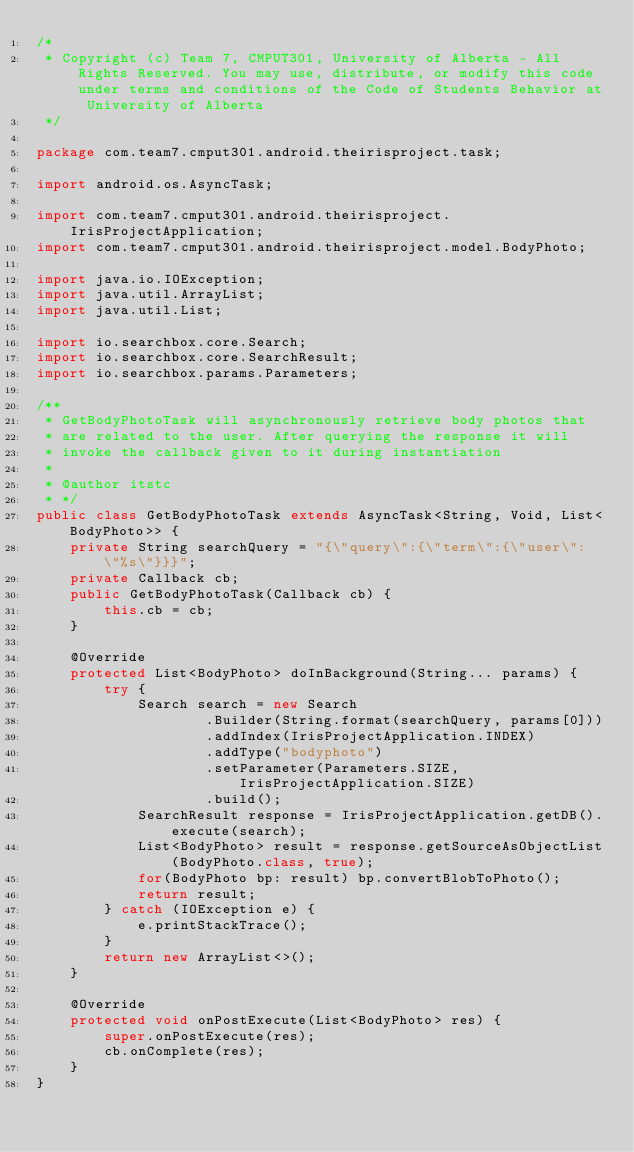Convert code to text. <code><loc_0><loc_0><loc_500><loc_500><_Java_>/*
 * Copyright (c) Team 7, CMPUT301, University of Alberta - All Rights Reserved. You may use, distribute, or modify this code under terms and conditions of the Code of Students Behavior at University of Alberta
 */

package com.team7.cmput301.android.theirisproject.task;

import android.os.AsyncTask;

import com.team7.cmput301.android.theirisproject.IrisProjectApplication;
import com.team7.cmput301.android.theirisproject.model.BodyPhoto;

import java.io.IOException;
import java.util.ArrayList;
import java.util.List;

import io.searchbox.core.Search;
import io.searchbox.core.SearchResult;
import io.searchbox.params.Parameters;

/**
 * GetBodyPhotoTask will asynchronously retrieve body photos that
 * are related to the user. After querying the response it will
 * invoke the callback given to it during instantiation
 *
 * @author itstc
 * */
public class GetBodyPhotoTask extends AsyncTask<String, Void, List<BodyPhoto>> {
    private String searchQuery = "{\"query\":{\"term\":{\"user\": \"%s\"}}}";
    private Callback cb;
    public GetBodyPhotoTask(Callback cb) {
        this.cb = cb;
    }

    @Override
    protected List<BodyPhoto> doInBackground(String... params) {
        try {
            Search search = new Search
                    .Builder(String.format(searchQuery, params[0]))
                    .addIndex(IrisProjectApplication.INDEX)
                    .addType("bodyphoto")
                    .setParameter(Parameters.SIZE, IrisProjectApplication.SIZE)
                    .build();
            SearchResult response = IrisProjectApplication.getDB().execute(search);
            List<BodyPhoto> result = response.getSourceAsObjectList(BodyPhoto.class, true);
            for(BodyPhoto bp: result) bp.convertBlobToPhoto();
            return result;
        } catch (IOException e) {
            e.printStackTrace();
        }
        return new ArrayList<>();
    }

    @Override
    protected void onPostExecute(List<BodyPhoto> res) {
        super.onPostExecute(res);
        cb.onComplete(res);
    }
}
</code> 